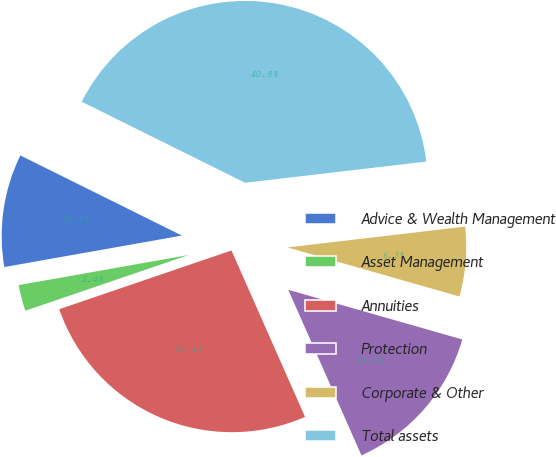<chart> <loc_0><loc_0><loc_500><loc_500><pie_chart><fcel>Advice & Wealth Management<fcel>Asset Management<fcel>Annuities<fcel>Protection<fcel>Corporate & Other<fcel>Total assets<nl><fcel>10.12%<fcel>2.44%<fcel>26.39%<fcel>13.95%<fcel>6.28%<fcel>40.81%<nl></chart> 